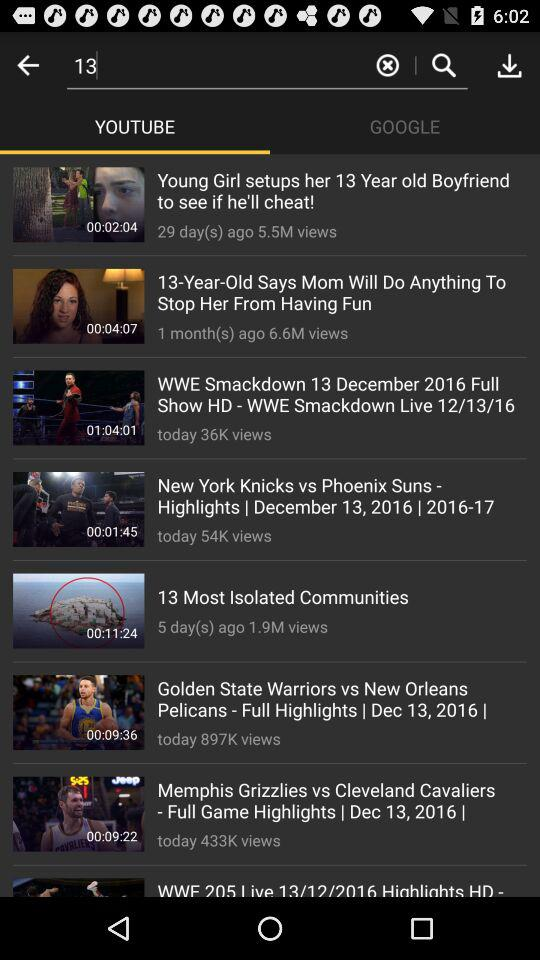How many views did the video "New York Knicks vs Phoenix Suns - Highlights" get? The video got 54K views. 